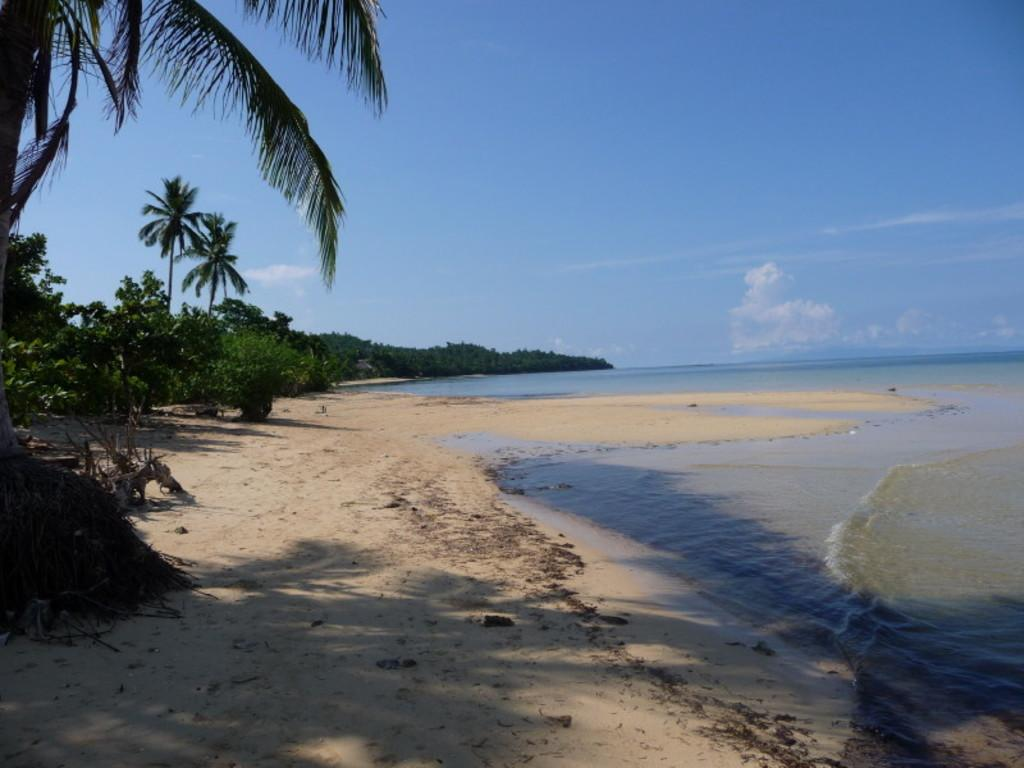What type of terrain is visible in the image? There is sand in the image. What else can be seen in the image besides sand? There is water and trees in the image. How are the trees in the image described? The trees are green and brown in color. What is visible in the background of the image? The sky is visible in the background of the image. Where are the cherries placed in the image? There are no cherries present in the image. What type of toys can be seen in the image? There are no toys present in the image. 